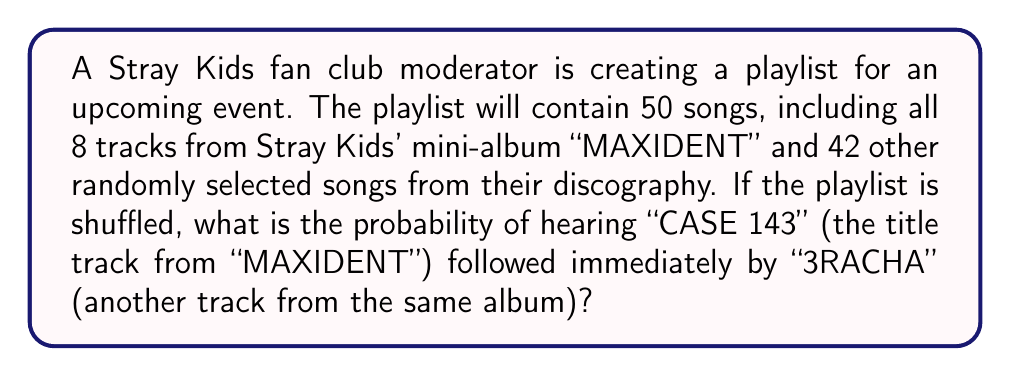Can you answer this question? Let's approach this step-by-step:

1) First, we need to calculate the probability of "CASE 143" playing:
   $P(\text{CASE 143}) = \frac{1}{50}$

2) After "CASE 143" plays, there are 49 songs left in the playlist.

3) For "3RACHA" to play immediately after, it needs to be selected from these 49 songs.
   $P(\text{3RACHA | CASE 143 played}) = \frac{1}{49}$

4) The probability of both events occurring in this specific order is the product of their individual probabilities:

   $$P(\text{CASE 143 then 3RACHA}) = P(\text{CASE 143}) \times P(\text{3RACHA | CASE 143 played})$$

5) Substituting the values:

   $$P(\text{CASE 143 then 3RACHA}) = \frac{1}{50} \times \frac{1}{49} = \frac{1}{2450}$$

Therefore, the probability of hearing "CASE 143" followed immediately by "3RACHA" is $\frac{1}{2450}$ or approximately 0.0004082.
Answer: $\frac{1}{2450}$ 